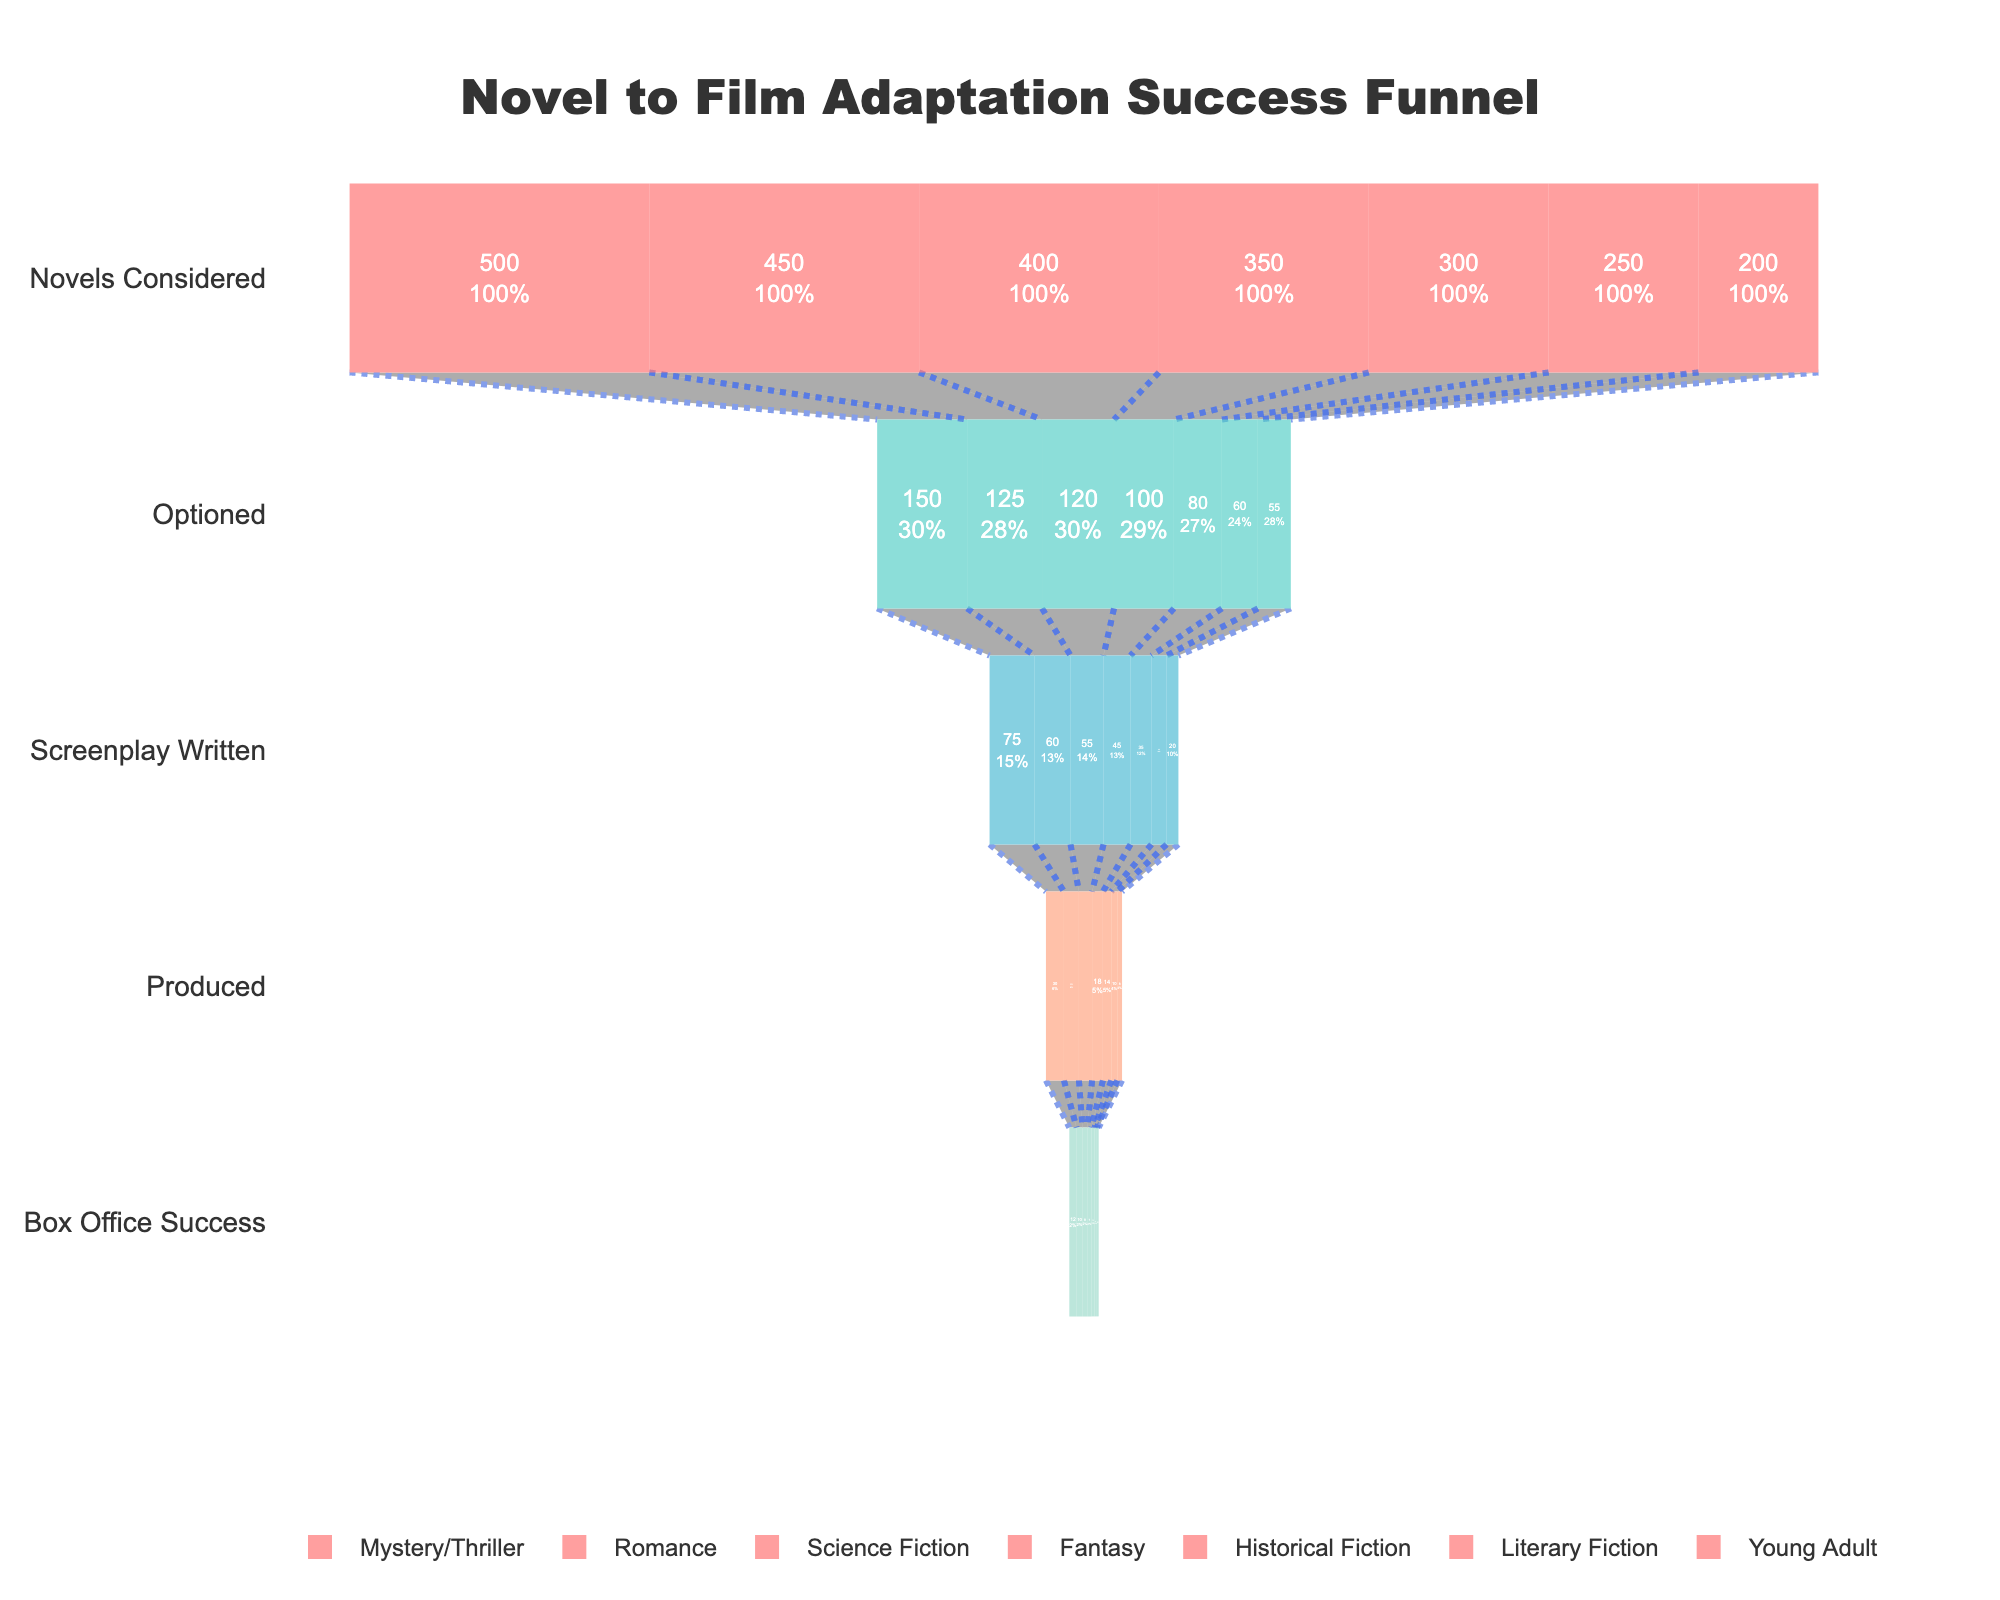What's the title of the chart? The title is located at the top of the chart in a prominent position and is usually presented in a larger font size to describe the overall topic or theme of the visualization.
Answer: Novel to Film Adaptation Success Funnel Which genre has the highest number of novels considered? The highest number in the "Novels Considered" stage for a genre indicates it has more novels initially evaluated for adaptation.
Answer: Mystery/Thriller What's the total number of novels that reached the Box Office Success stage across all genres? To find this, sum up the values in the "Box Office Success" stage for all genres: 12 (Mystery/Thriller) + 10 (Romance) + 8 (Science Fiction) + 7 (Fantasy) + 5 (Historical Fiction) + 4 (Literary Fiction) + 3 (Young Adult).
Answer: 49 Which genre has the lowest percentage of novels that reached the Screenplay Written stage relative to the number of novels considered? To calculate the percentage, divide the number of Screenplay Written by Novels Considered for each genre and compare: 
Mystery/Thriller: 75/500 = 0.15
Romance: 60/450 = 0.133
Science Fiction: 55/400 = 0.1375
Fantasy: 45/350 = 0.1285
Historical Fiction: 35/300 = 0.1166
Literary Fiction: 25/250 = 0.1
Young Adult: 20/200 = 0.1. 
Literary Fiction and Young Adult have the lowest percentage.
Answer: Literary Fiction and Young Adult Which genre shows the most significant drop-off from the Produced stage to the Box Office Success stage? Compare the difference between the Produced and Box Office Success stages for each genre, and determine the largest drop-off: 
Mystery/Thriller: 30 - 12 = 18
Romance: 25 - 10 = 15
Science Fiction: 22 - 8 = 14
Fantasy: 18 - 7 = 11
Historical Fiction: 14 - 5 = 9
Literary Fiction: 10 - 4 = 6
Young Adult: 8 - 3 = 5. 
The genre with the highest drop-off is Mystery/Thriller.
Answer: Mystery/Thriller What percentage of Romance novels considered were eventually produced into films? Calculate the percentage by dividing the number of Produced by Novels Considered for the Romance genre and multiply by 100: (25/450) * 100.
Answer: 5.56% Among the genres, which has the highest success rate from being optioned to becoming a box office success? Calculate the success rate for each genre by dividing the Box Office Success by Optioned and compare:
Mystery/Thriller: 12/150 = 0.08
Romance: 10/125 = 0.08
Science Fiction: 8/120 = 0.0667
Fantasy: 7/100 = 0.07
Historical Fiction: 5/80 = 0.0625
Literary Fiction: 4/60 = 0.0667
Young Adult: 3/55 = 0.0545. 
Mystery/Thriller and Romance have the highest success rate.
Answer: Mystery/Thriller and Romance What is the overall trend visible in the funnel chart for novel adaptations? Generally, the number of novels decreases significantly at each successive stage, indicating a high drop-off rate from consideration to box office success.
Answer: High drop-off rate 